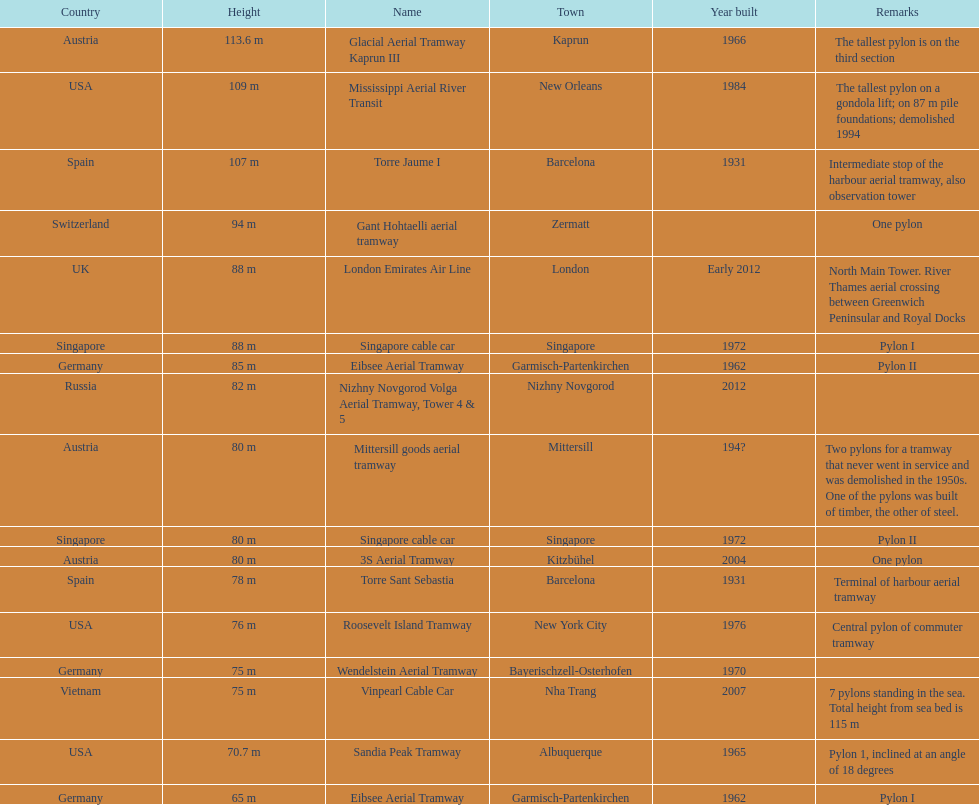How many pylons have a height of at least 80 meters? 11. 